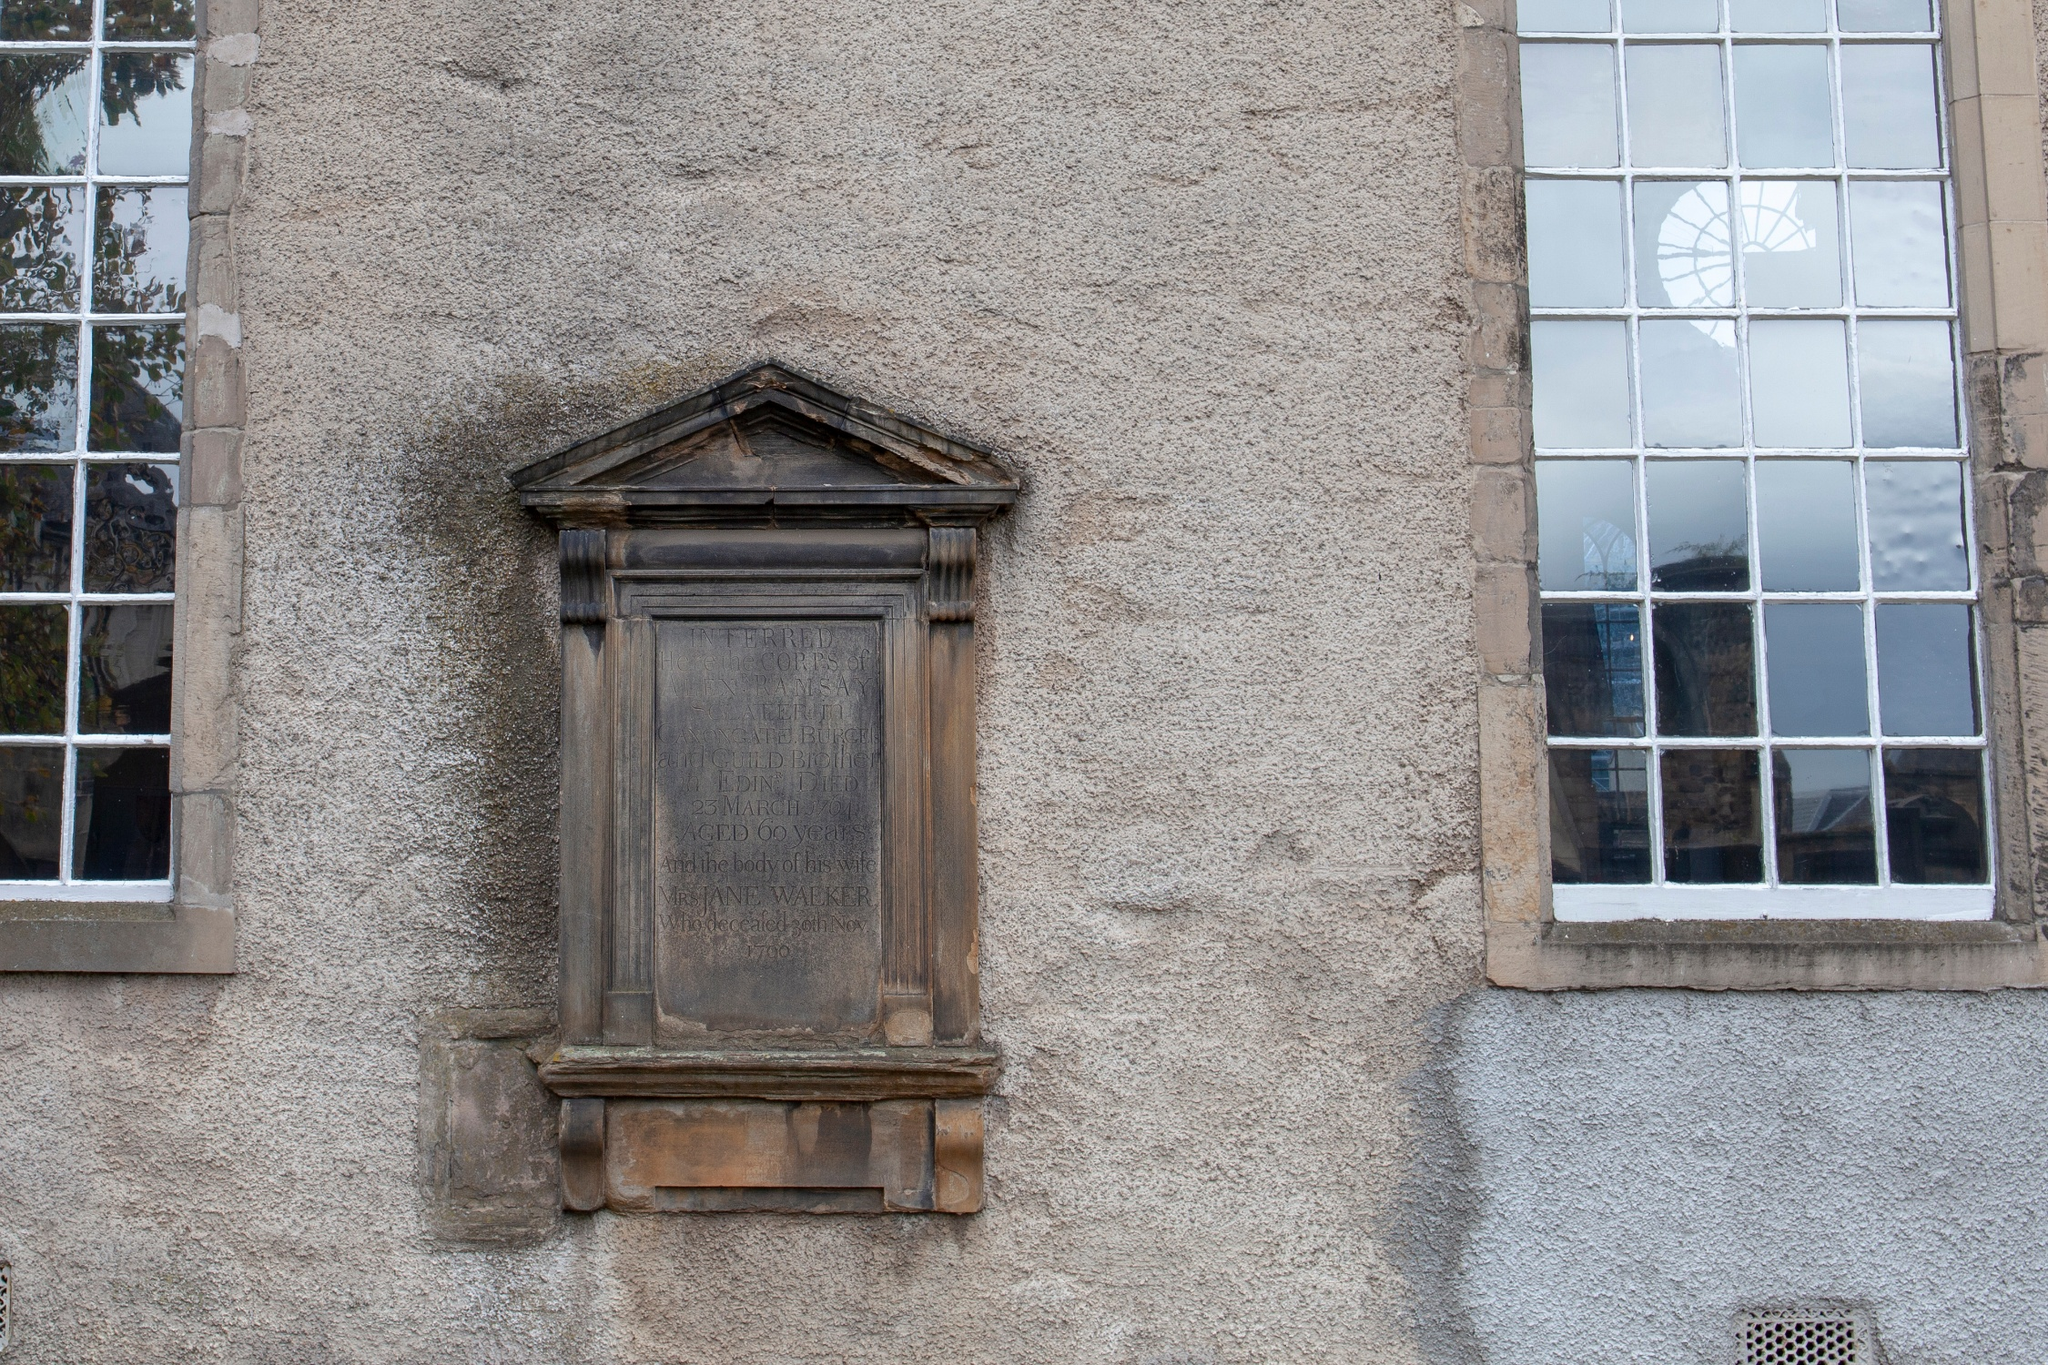What could be the historical significance of the plaque on the building? The plaque, although weathered and hard to read, appears to be a commemorative marker, possibly acknowledging an event or an individual relevant to the building's history. It features a classic design with a carved wooden frame and an eroded inscription. If legible, it could offer insights into the building’s past, perhaps dating back to the 17th or 18th century, which could be tied to local or national history. Such plaques often indicate a place's historical or cultural significance. 